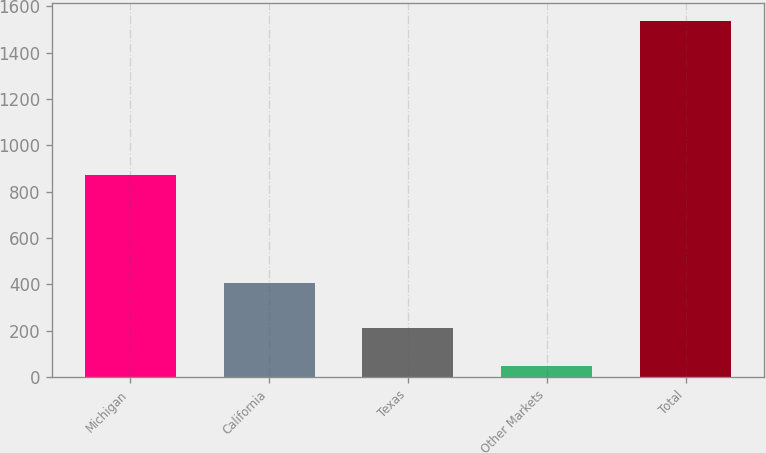Convert chart. <chart><loc_0><loc_0><loc_500><loc_500><bar_chart><fcel>Michigan<fcel>California<fcel>Texas<fcel>Other Markets<fcel>Total<nl><fcel>871<fcel>404<fcel>212<fcel>50<fcel>1537<nl></chart> 